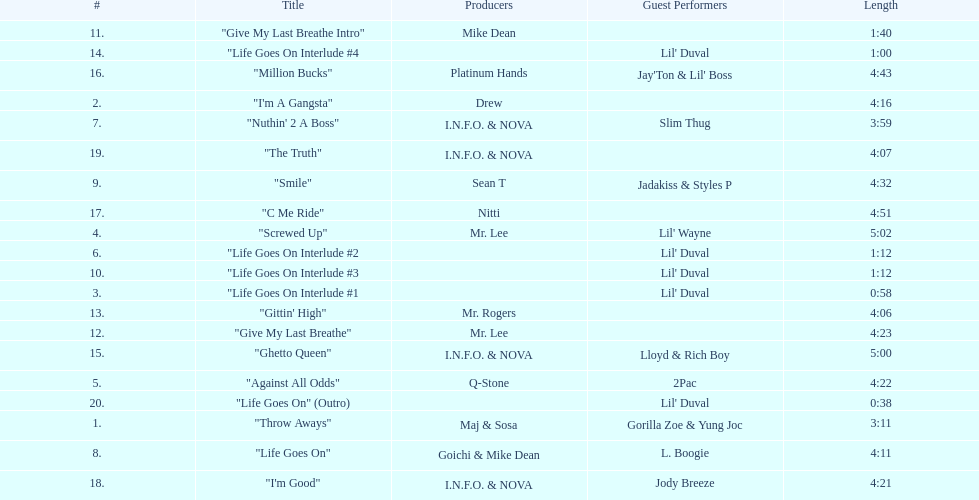Which tracks feature the same producer(s) in consecutive order on this album? "I'm Good", "The Truth". 